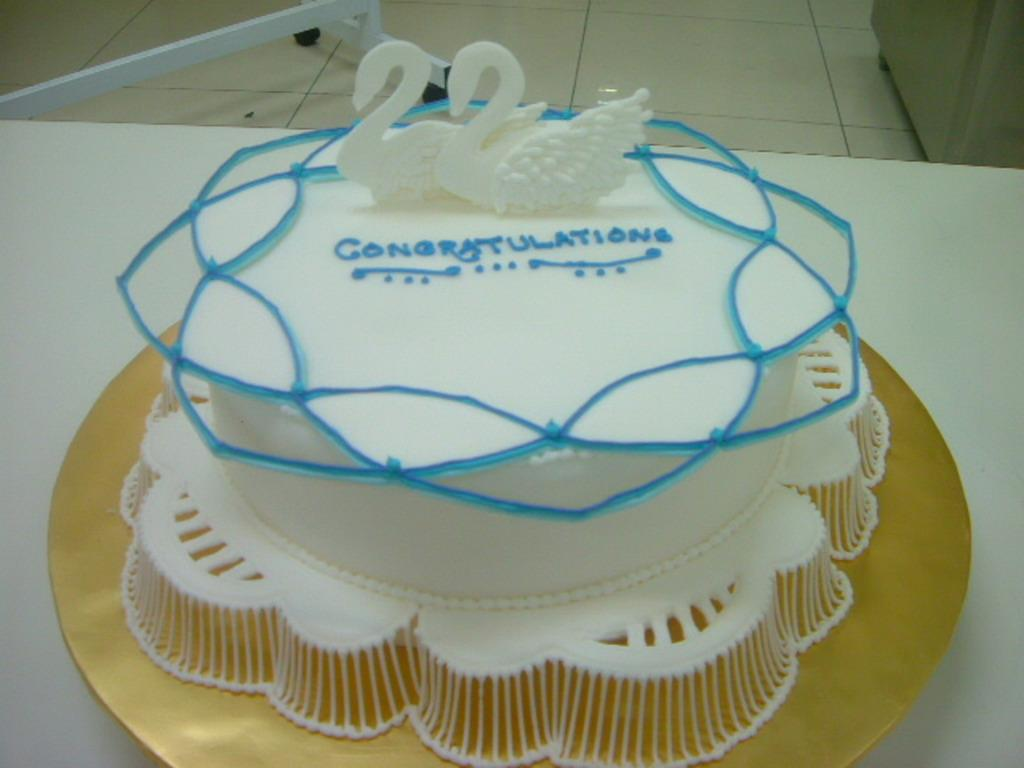What is the main subject on the table in the image? There is a cake on a table in the image. Can you describe any other objects or structures visible in the image? There is a stand on the floor in the background of the image. What type of quilt is draped over the cake in the image? There is no quilt present in the image, and the cake is not covered by any fabric. Can you see any firemen in the image? There is no fireman present in the image. 